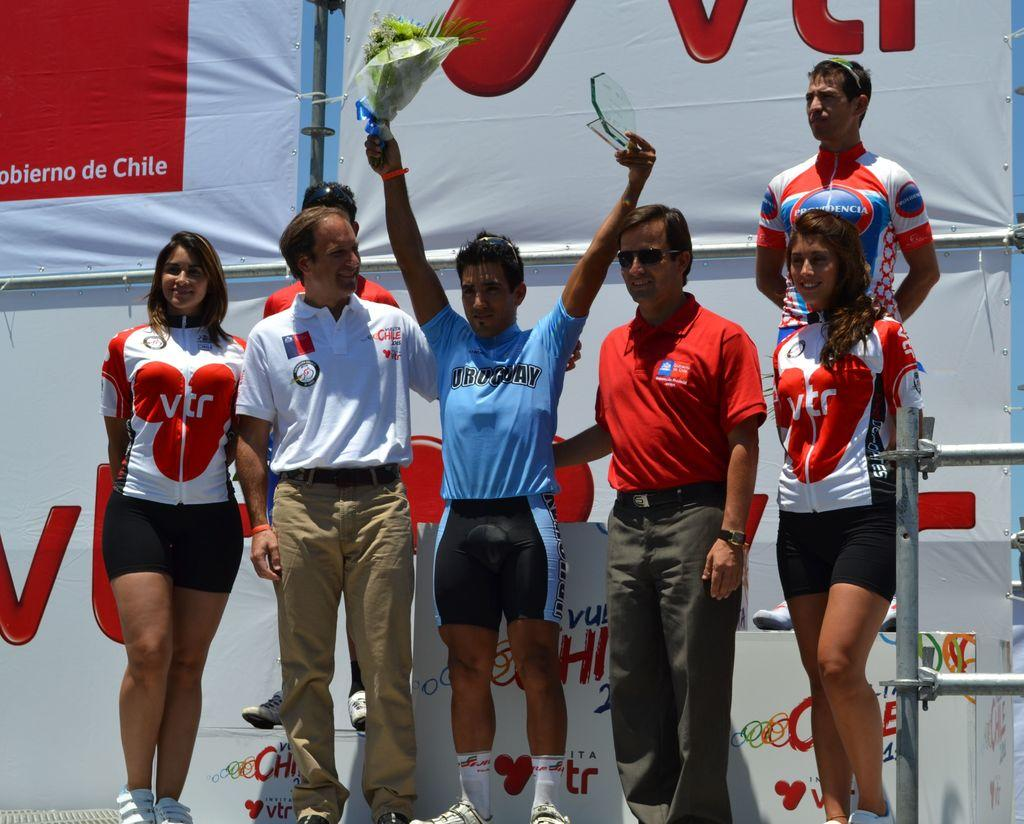<image>
Create a compact narrative representing the image presented. An athlete from the country of Uruguay celebrates a victory. 